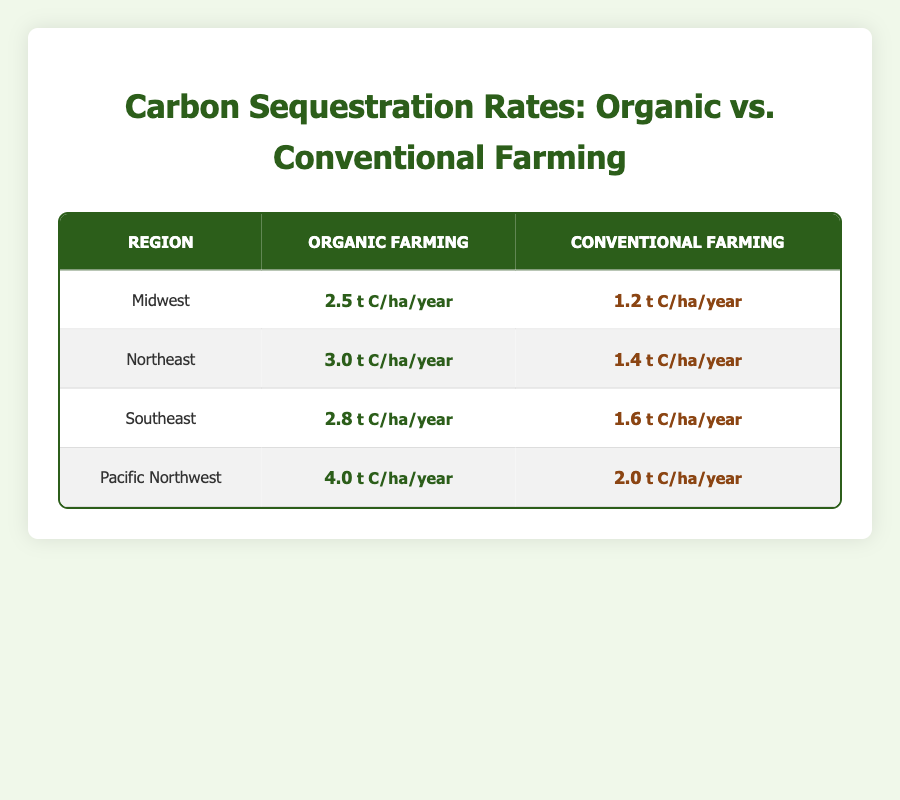What is the carbon sequestration rate for organic farming in the Midwest? The table lists the carbon sequestration rate for organic farming in the Midwest as 2.5 t C/ha/year.
Answer: 2.5 t C/ha/year What is the carbon sequestration rate for conventional farming in the Pacific Northwest? The table shows that the carbon sequestration rate for conventional farming in the Pacific Northwest is 2.0 t C/ha/year.
Answer: 2.0 t C/ha/year Which region has the highest carbon sequestration rate for organic farming? Looking at the organic farming rates, the Pacific Northwest has the highest rate at 4.0 t C/ha/year, as seen in the respective row of the table.
Answer: Pacific Northwest Is the carbon sequestration rate for organic farming greater than that for conventional farming in the Southeast? In the Southeast, the organic farming rate is 2.8 t C/ha/year while the conventional rate is 1.6 t C/ha/year. Since 2.8 is greater than 1.6, the answer is yes.
Answer: Yes What is the difference in carbon sequestration rates between organic and conventional farming in the Northeast? For the Northeast, the organic rate is 3.0 t C/ha/year and the conventional rate is 1.4 t C/ha/year. The difference can be calculated by subtracting the conventional rate from the organic rate: 3.0 - 1.4 = 1.6.
Answer: 1.6 t C/ha/year What is the average carbon sequestration rate for organic farming across all regions? Adding the rates for organic farming: 2.5 (Midwest) + 3.0 (Northeast) + 2.8 (Southeast) + 4.0 (Pacific Northwest) gives a total of 12.3. There are 4 regions, so the average is 12.3 / 4 = 3.075.
Answer: 3.075 t C/ha/year Have all regions shown higher carbon sequestration rates for organic farming compared to conventional farming? By examining each region, organic rates are higher in Midwest (2.5 vs 1.2), Northeast (3.0 vs 1.4), Southeast (2.8 vs 1.6), and Pacific Northwest (4.0 vs 2.0). Thus, the answer is yes.
Answer: Yes What is the total carbon sequestration rate for all regions combined for conventional farming? Summing the conventional farming rates: 1.2 (Midwest) + 1.4 (Northeast) + 1.6 (Southeast) + 2.0 (Pacific Northwest) results in a total of 6.2 t C/ha/year.
Answer: 6.2 t C/ha/year Is the carbon sequestration rate for organic farming in the Midwest lower than that in the Southeast? The organic rate in the Midwest is 2.5 t C/ha/year, while in the Southeast it is 2.8 t C/ha/year. Since 2.5 is less than 2.8, the answer is yes.
Answer: Yes 